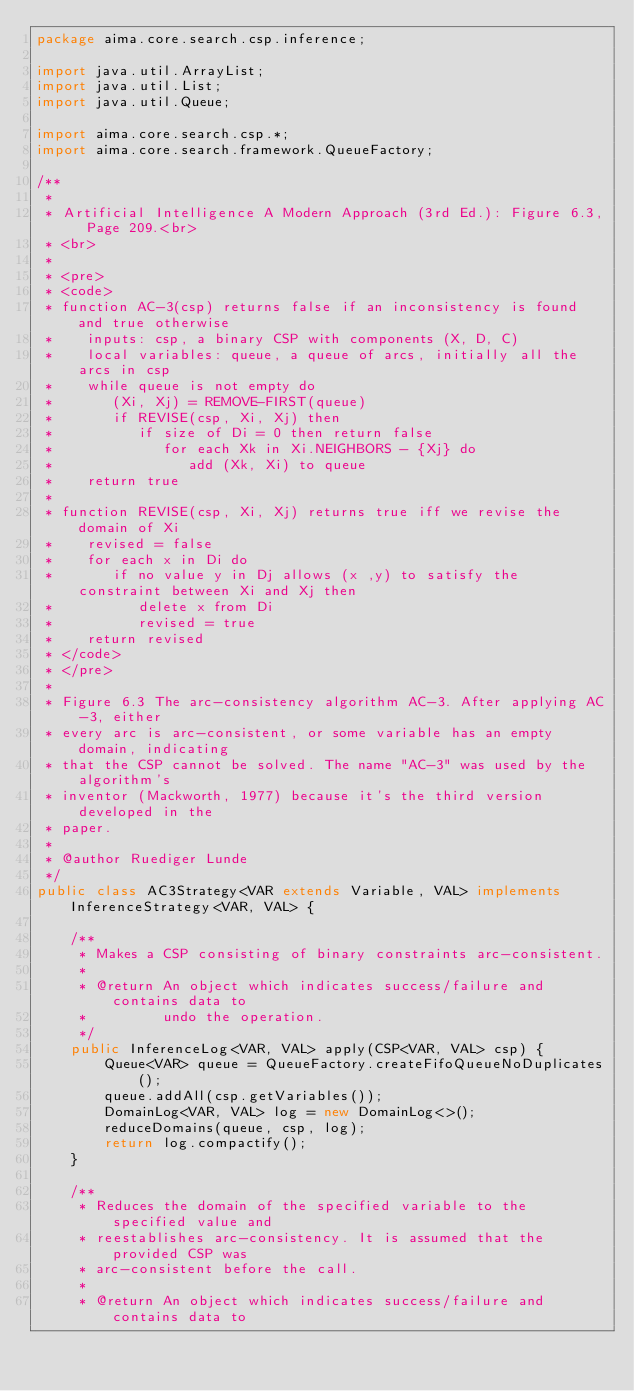<code> <loc_0><loc_0><loc_500><loc_500><_Java_>package aima.core.search.csp.inference;

import java.util.ArrayList;
import java.util.List;
import java.util.Queue;

import aima.core.search.csp.*;
import aima.core.search.framework.QueueFactory;

/**
 * 
 * Artificial Intelligence A Modern Approach (3rd Ed.): Figure 6.3, Page 209.<br>
 * <br>
 * 
 * <pre>
 * <code>
 * function AC-3(csp) returns false if an inconsistency is found and true otherwise
 *    inputs: csp, a binary CSP with components (X, D, C)
 *    local variables: queue, a queue of arcs, initially all the arcs in csp
 *    while queue is not empty do
 *       (Xi, Xj) = REMOVE-FIRST(queue)
 *       if REVISE(csp, Xi, Xj) then
 *          if size of Di = 0 then return false
 *             for each Xk in Xi.NEIGHBORS - {Xj} do
 *                add (Xk, Xi) to queue
 *    return true
 * 
 * function REVISE(csp, Xi, Xj) returns true iff we revise the domain of Xi
 *    revised = false
 *    for each x in Di do
 *       if no value y in Dj allows (x ,y) to satisfy the constraint between Xi and Xj then
 *          delete x from Di
 *          revised = true
 *    return revised
 * </code>
 * </pre>
 * 
 * Figure 6.3 The arc-consistency algorithm AC-3. After applying AC-3, either
 * every arc is arc-consistent, or some variable has an empty domain, indicating
 * that the CSP cannot be solved. The name "AC-3" was used by the algorithm's
 * inventor (Mackworth, 1977) because it's the third version developed in the
 * paper.
 * 
 * @author Ruediger Lunde
 */
public class AC3Strategy<VAR extends Variable, VAL> implements InferenceStrategy<VAR, VAL> {

	/**
	 * Makes a CSP consisting of binary constraints arc-consistent.
	 * 
	 * @return An object which indicates success/failure and contains data to
	 *         undo the operation.
	 */
	public InferenceLog<VAR, VAL> apply(CSP<VAR, VAL> csp) {
		Queue<VAR> queue = QueueFactory.createFifoQueueNoDuplicates();
		queue.addAll(csp.getVariables());
		DomainLog<VAR, VAL> log = new DomainLog<>();
		reduceDomains(queue, csp, log);
		return log.compactify();
	}

	/**
	 * Reduces the domain of the specified variable to the specified value and
	 * reestablishes arc-consistency. It is assumed that the provided CSP was
	 * arc-consistent before the call.
	 * 
	 * @return An object which indicates success/failure and contains data to</code> 